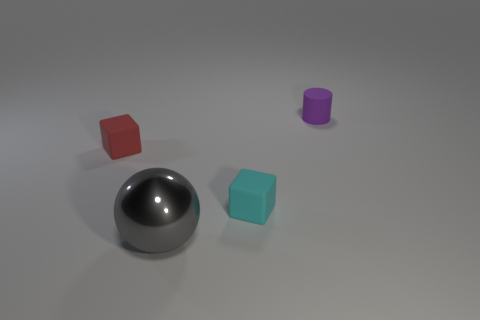Add 4 blue matte cylinders. How many objects exist? 8 Add 2 purple cylinders. How many purple cylinders are left? 3 Add 1 gray metallic balls. How many gray metallic balls exist? 2 Subtract 0 green blocks. How many objects are left? 4 Subtract all big purple rubber spheres. Subtract all tiny red objects. How many objects are left? 3 